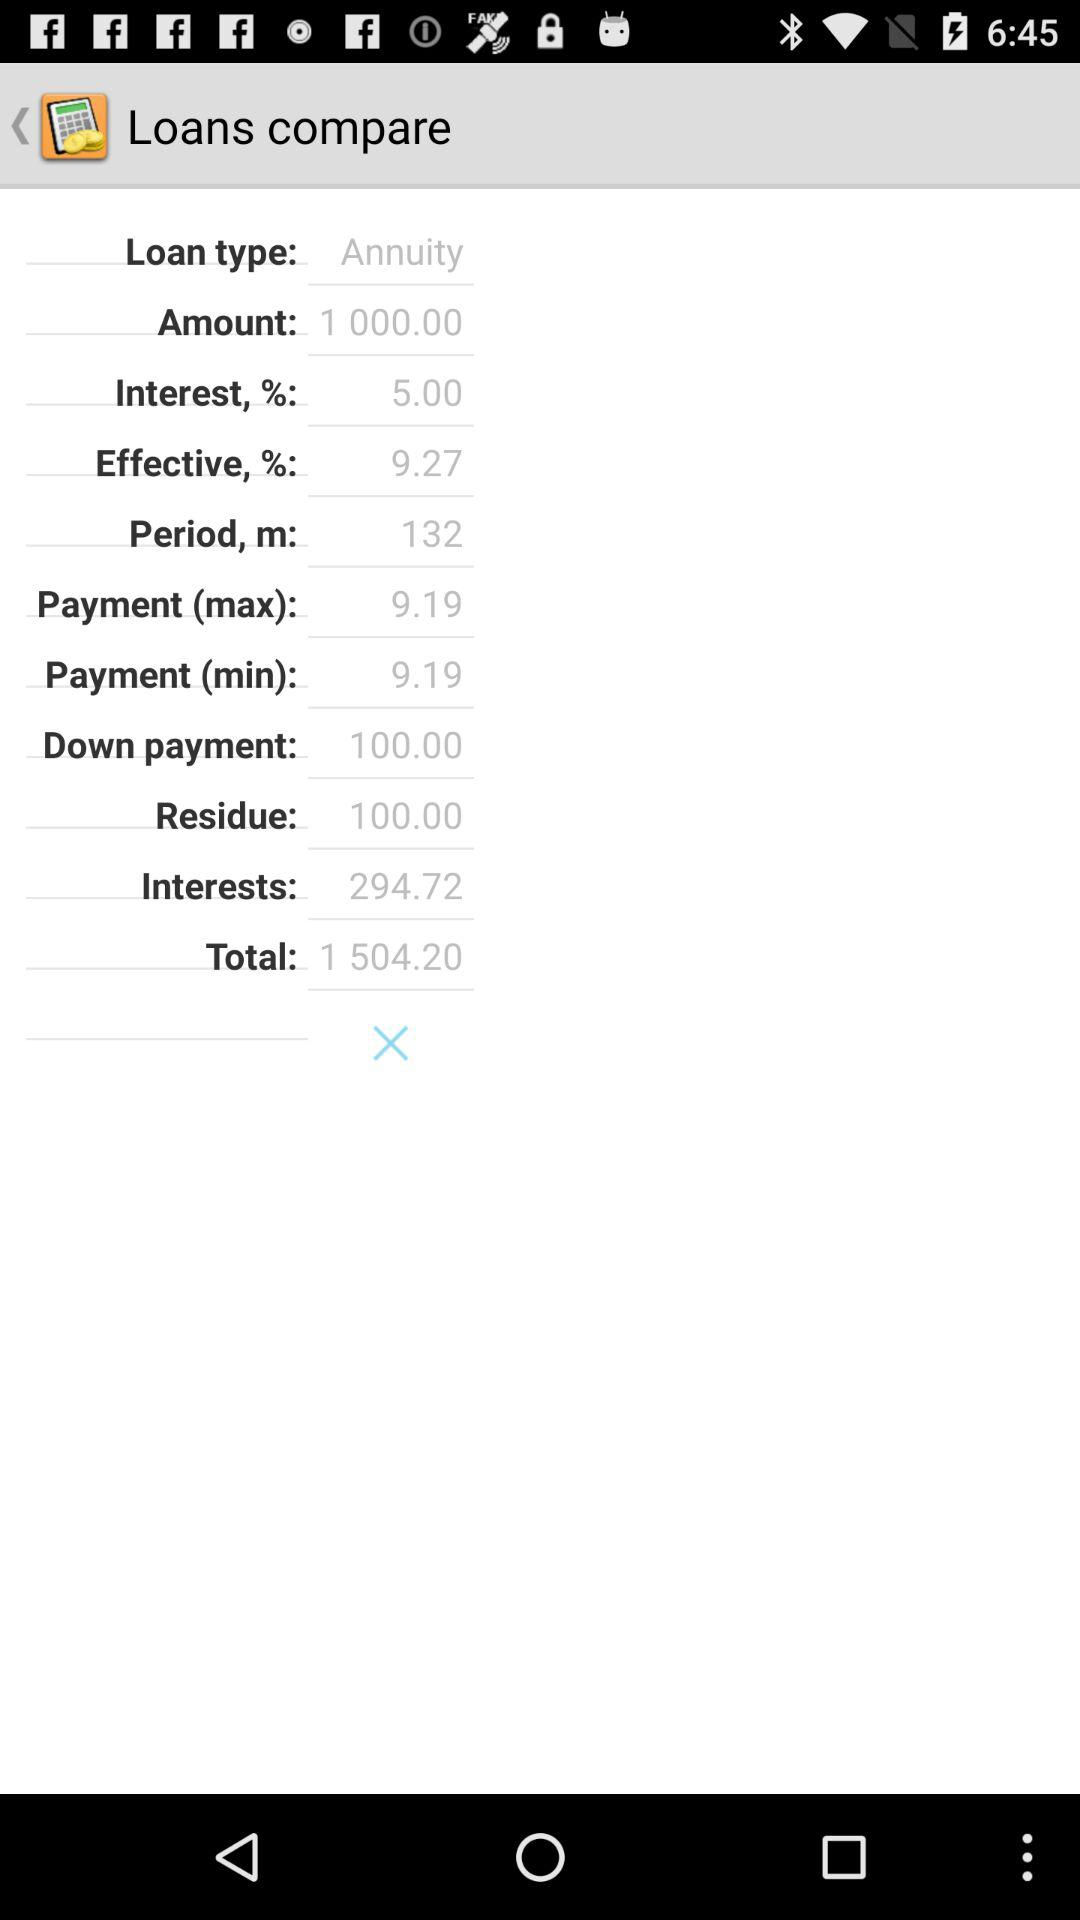What is the residue amount? The residue amount is 100. 